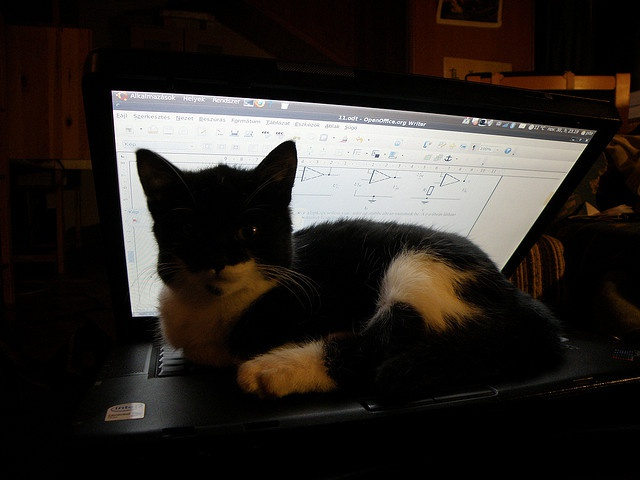Describe the objects in this image and their specific colors. I can see a laptop in black, lightgray, darkgray, and gray tones in this image. 